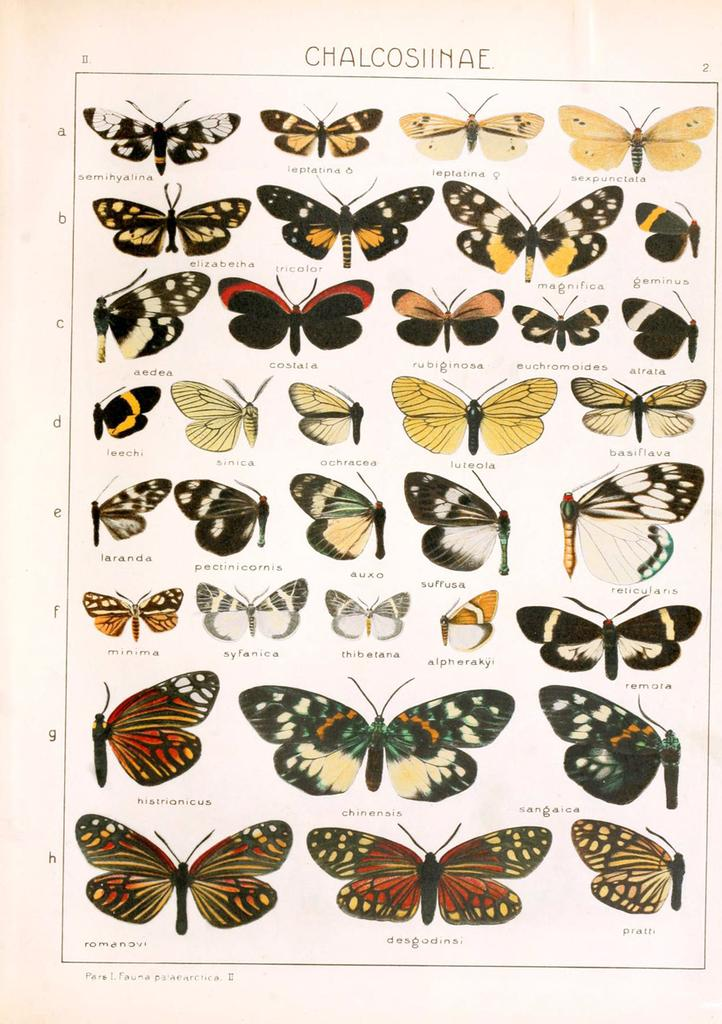What is featured in the image? There is a poster in the image. What is depicted on the poster? The poster contains butterflies. Are there any words on the poster? Yes, there is text on the poster. What type of music can be heard playing in the background of the image? There is no music playing in the background of the image; it only features a poster with butterflies and text. 